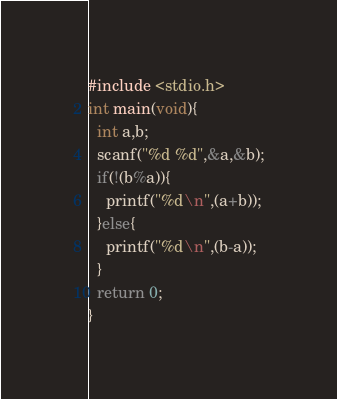<code> <loc_0><loc_0><loc_500><loc_500><_C_>#include <stdio.h>
int main(void){
  int a,b;
  scanf("%d %d",&a,&b);
  if(!(b%a)){
    printf("%d\n",(a+b));
  }else{
    printf("%d\n",(b-a));
  }
  return 0;
}</code> 